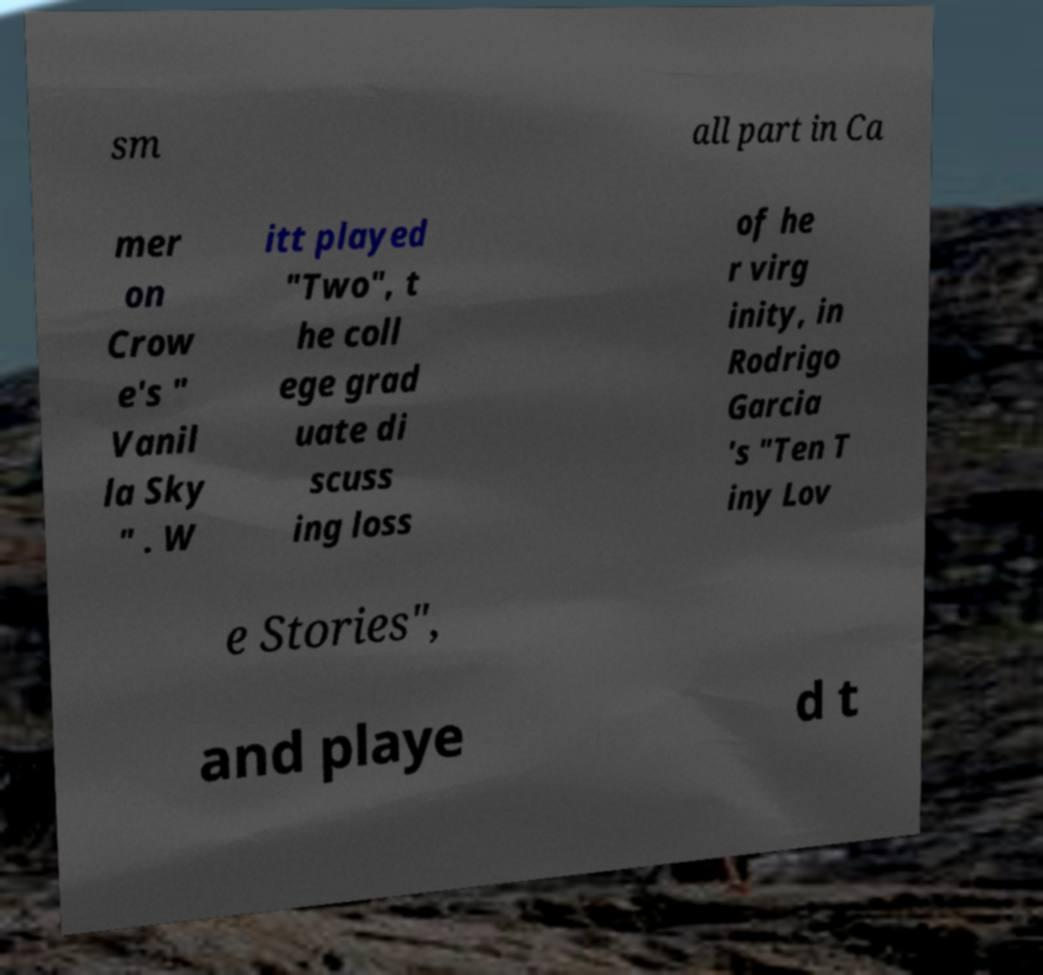Can you read and provide the text displayed in the image?This photo seems to have some interesting text. Can you extract and type it out for me? sm all part in Ca mer on Crow e's " Vanil la Sky " . W itt played "Two", t he coll ege grad uate di scuss ing loss of he r virg inity, in Rodrigo Garcia 's "Ten T iny Lov e Stories", and playe d t 